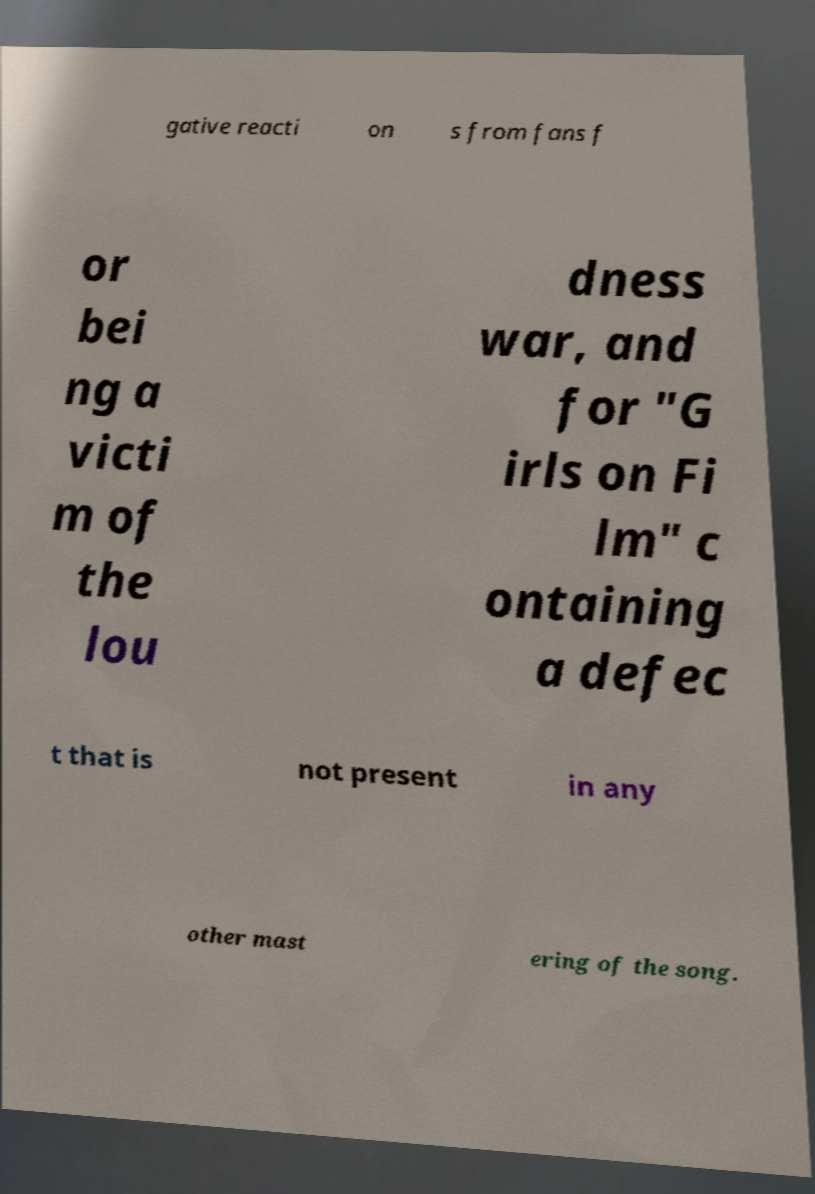There's text embedded in this image that I need extracted. Can you transcribe it verbatim? gative reacti on s from fans f or bei ng a victi m of the lou dness war, and for "G irls on Fi lm" c ontaining a defec t that is not present in any other mast ering of the song. 